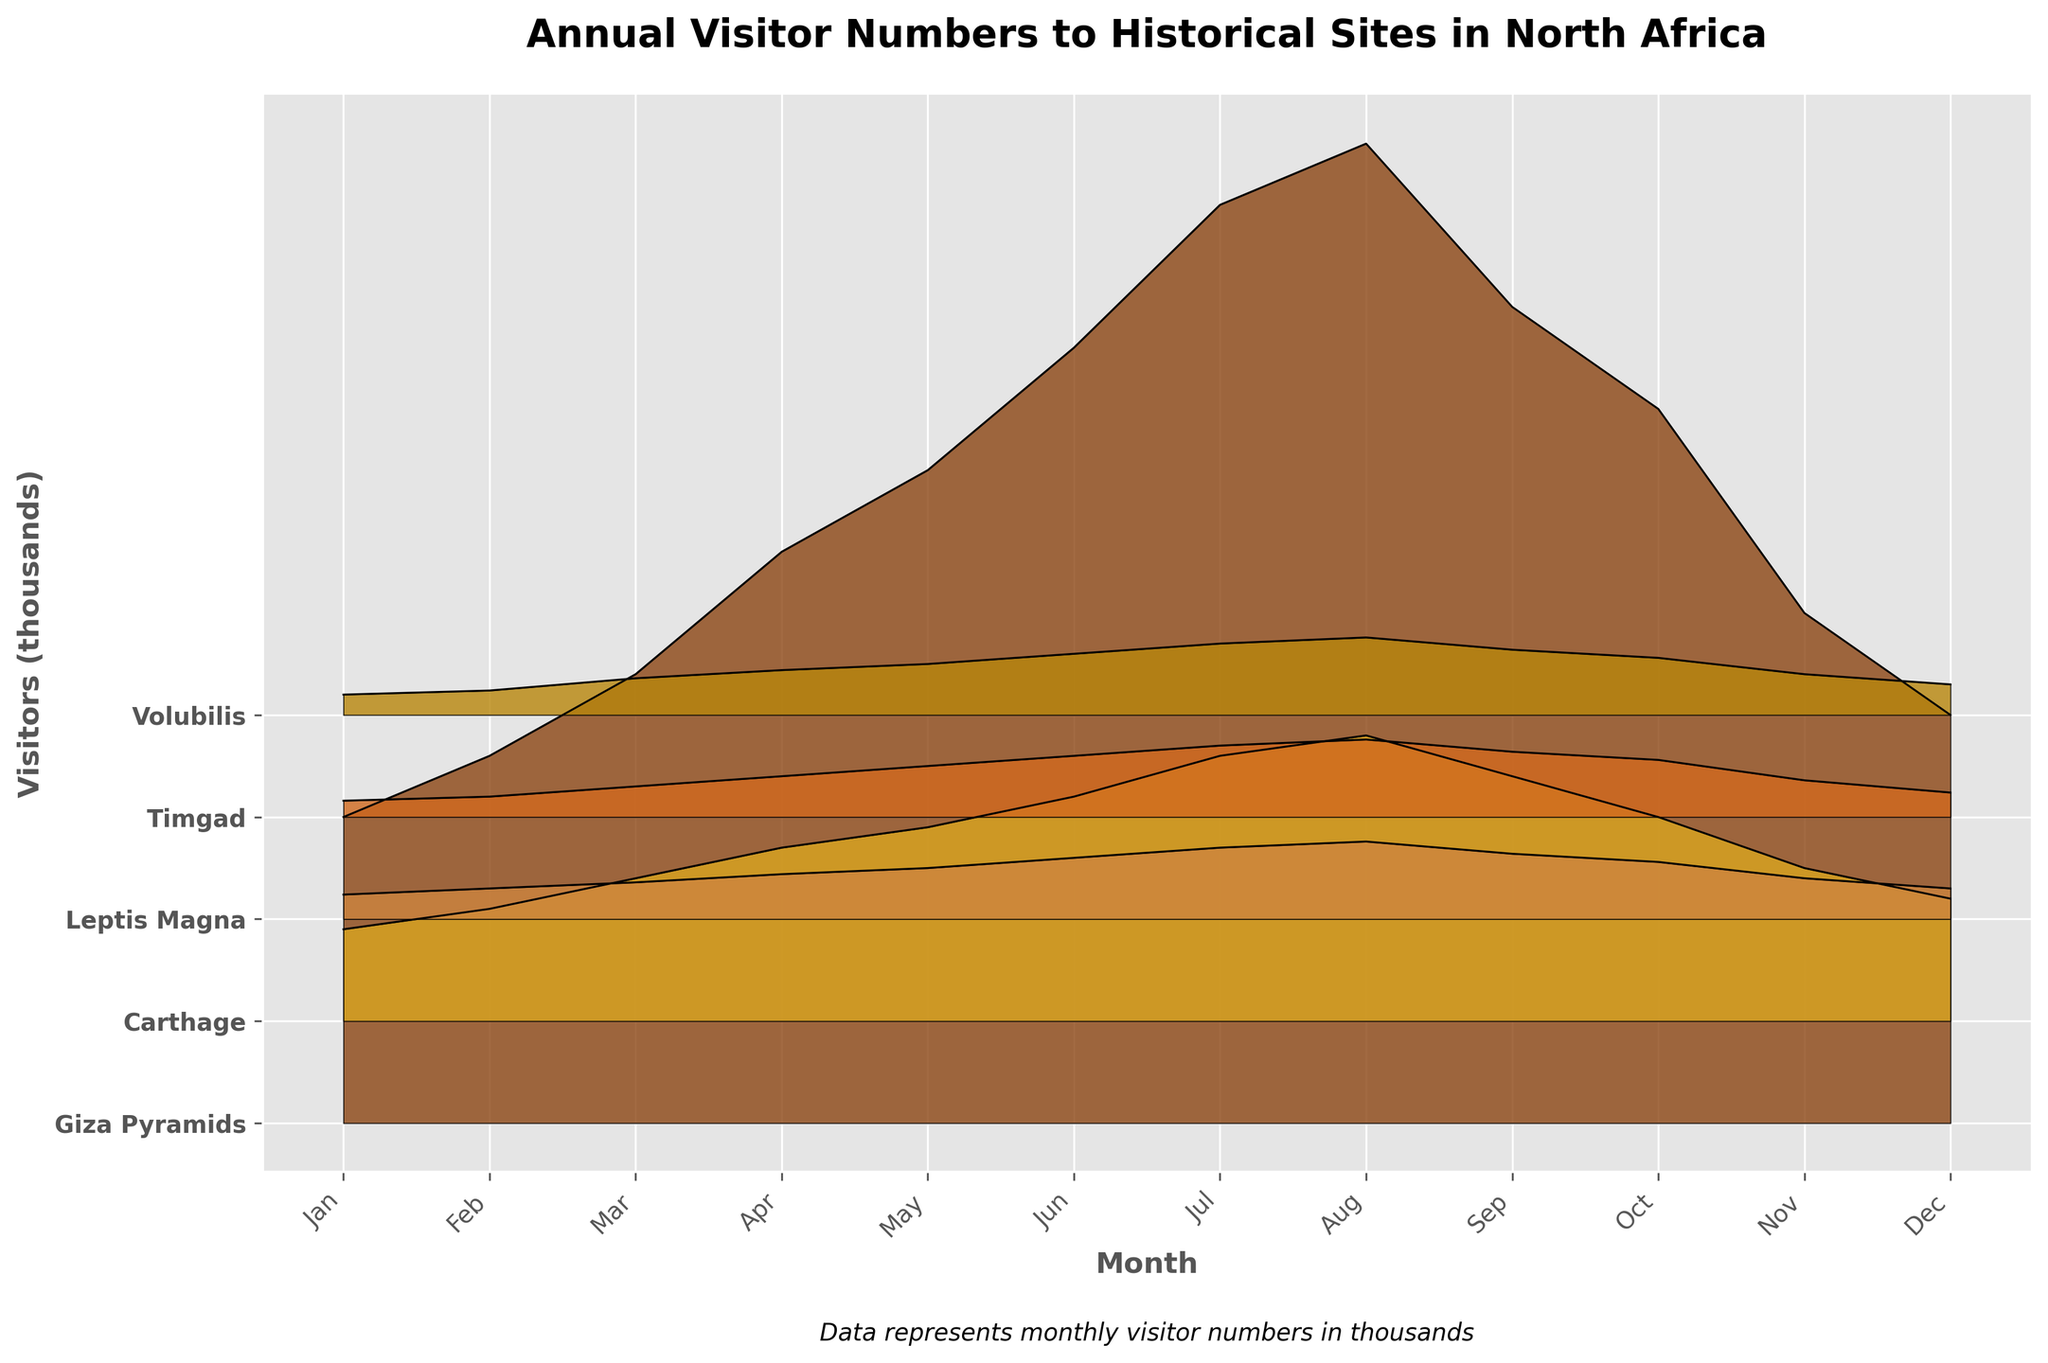What's the title of the plot? The title of the plot is located at the top center and it reads "Annual Visitor Numbers to Historical Sites in North Africa".
Answer: Annual Visitor Numbers to Historical Sites in North Africa How many historical sites are represented in the plot? By looking at the number of colored regions, which represent historical sites, and matching them with the legend, we can see there are five historical sites depicted.
Answer: Five Which historical site had the highest number of visitors in July? By observing the peaks of the colored regions for July, it is clear that the Giza Pyramids have the highest peak.
Answer: Giza Pyramids What is the color used to represent the Giza Pyramids' monthly visitor numbers? The Giza Pyramids' visitor numbers are represented by the darkest shade of brown region in the plot.
Answer: Dark Brown In which month did Carthage receive its highest visitor numbers? By tracking the peaks of the Carthage line (light/burnished gold color), it is evident that the highest number of visitors occurred in August.
Answer: August How many thousand visitors did Volubilis have in March? The peak of the Volubilis region (olive/golden brown) for March shows that around 18,000 visitors were recorded.
Answer: 18,000 Which two historical sites have the closest visitor numbers in June? By observing the ridges for June, Timgad and Volubilis both have a visitor count of around 30,000 each, making them have the closest numbers.
Answer: Timgad and Volubilis What is the average number of visitors to Leptis Magna in January and February? Leptis Magna had 12,000 visitors in January and 15,000 in February. (12,000 + 15,000) / 2 = 13,500 visitors on average.
Answer: 13,500 Across all months, which historical site appears to have the most consistently high visitor numbers? By visually comparing the height and consistency of all ridges throughout the months, the Giza Pyramids' ridge maintains the highest and most consistent visitor numbers.
Answer: Giza Pyramids What's the maximum number of visitors the Timgad site received in 2023 based on the plot, and in which month? Look at the peaks of the Timgad ridge (dark golden brown). The maximum number of visitors is seen in August with around 38,000 visitors.
Answer: 38,000 in August 